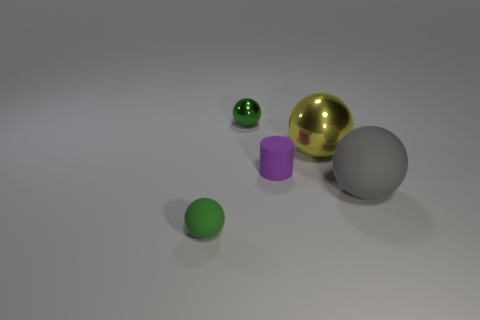Subtract all green spheres. How many were subtracted if there are1green spheres left? 1 Add 2 tiny cyan metallic spheres. How many objects exist? 7 Subtract all spheres. How many objects are left? 1 Subtract all large yellow things. Subtract all yellow metal things. How many objects are left? 3 Add 1 yellow things. How many yellow things are left? 2 Add 1 small purple cylinders. How many small purple cylinders exist? 2 Subtract 0 red cylinders. How many objects are left? 5 